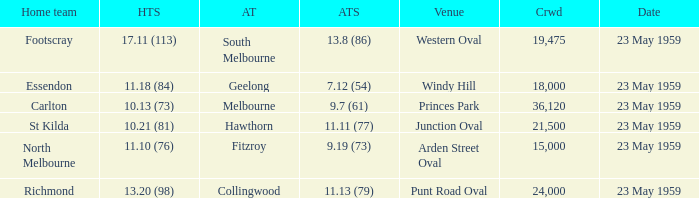What was the home team's score at the game held at Punt Road Oval? 13.20 (98). 